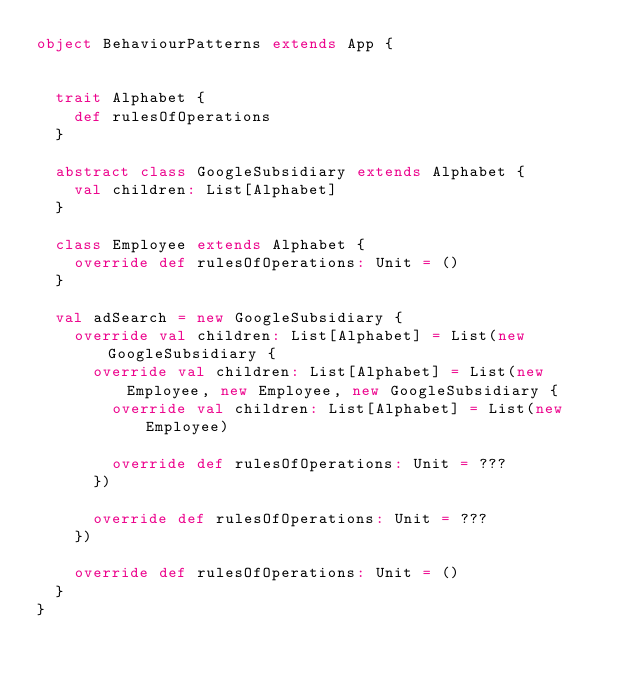Convert code to text. <code><loc_0><loc_0><loc_500><loc_500><_Scala_>object BehaviourPatterns extends App {
   
  
  trait Alphabet {
    def rulesOfOperations
  }

  abstract class GoogleSubsidiary extends Alphabet {
    val children: List[Alphabet]
  }

  class Employee extends Alphabet {
    override def rulesOfOperations: Unit = ()
  }

  val adSearch = new GoogleSubsidiary {
    override val children: List[Alphabet] = List(new GoogleSubsidiary {
      override val children: List[Alphabet] = List(new Employee, new Employee, new GoogleSubsidiary {
        override val children: List[Alphabet] = List(new Employee)

        override def rulesOfOperations: Unit = ???
      })

      override def rulesOfOperations: Unit = ???
    })

    override def rulesOfOperations: Unit = ()
  }
}</code> 